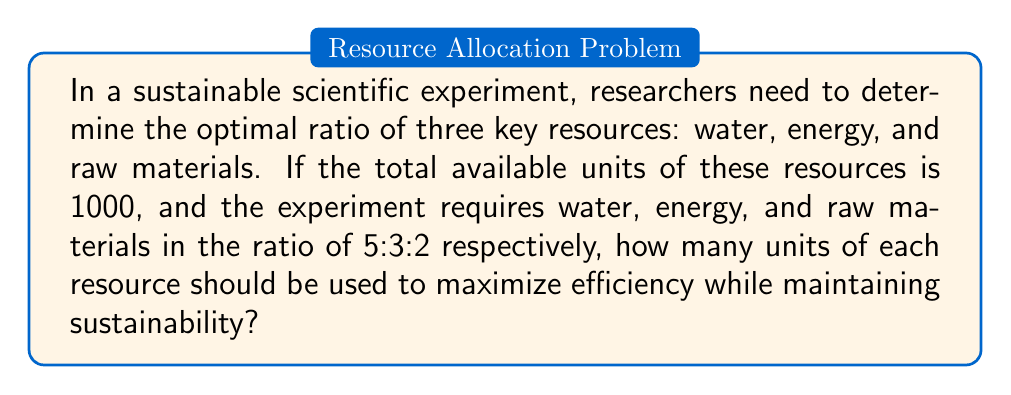Provide a solution to this math problem. To solve this problem, we'll follow these steps:

1. Understand the given ratio:
   Water : Energy : Raw Materials = 5 : 3 : 2

2. Calculate the total parts in the ratio:
   $5 + 3 + 2 = 10$ parts

3. Set up an equation to find the value of one part:
   Let $x$ be the value of one part.
   Then, $5x + 3x + 2x = 1000$
   $10x = 1000$

4. Solve for $x$:
   $x = 1000 \div 10 = 100$

5. Calculate the units for each resource:
   Water: $5x = 5 \times 100 = 500$ units
   Energy: $3x = 3 \times 100 = 300$ units
   Raw Materials: $2x = 2 \times 100 = 200$ units

6. Verify the total:
   $500 + 300 + 200 = 1000$ units (matches the given total)

Therefore, the optimal distribution of resources for this sustainable scientific experiment is 500 units of water, 300 units of energy, and 200 units of raw materials.
Answer: Water: 500 units, Energy: 300 units, Raw Materials: 200 units 